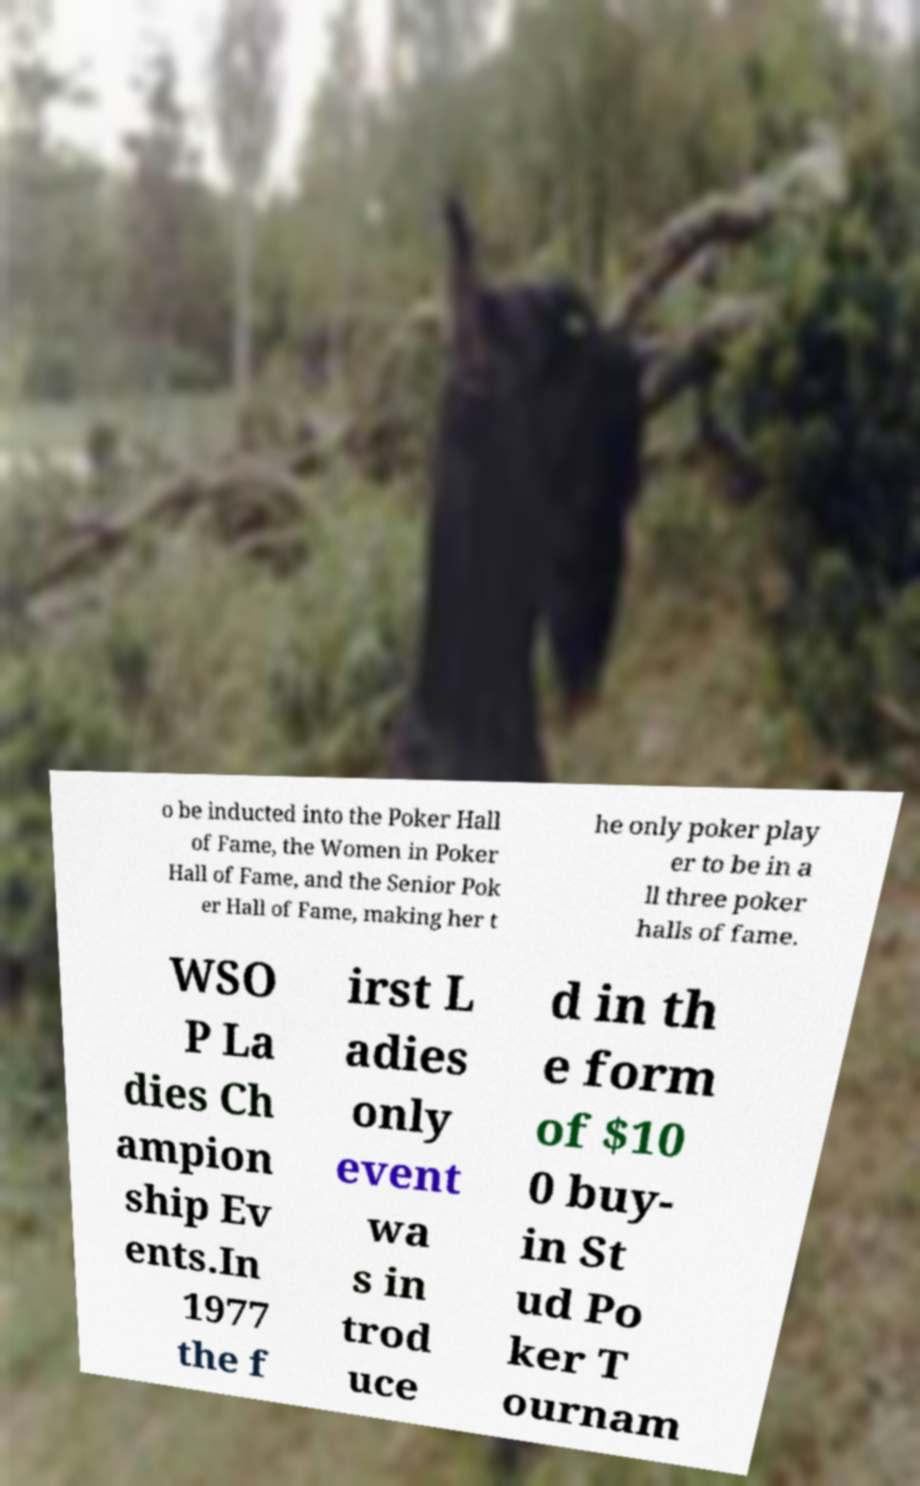Could you extract and type out the text from this image? o be inducted into the Poker Hall of Fame, the Women in Poker Hall of Fame, and the Senior Pok er Hall of Fame, making her t he only poker play er to be in a ll three poker halls of fame. WSO P La dies Ch ampion ship Ev ents.In 1977 the f irst L adies only event wa s in trod uce d in th e form of $10 0 buy- in St ud Po ker T ournam 